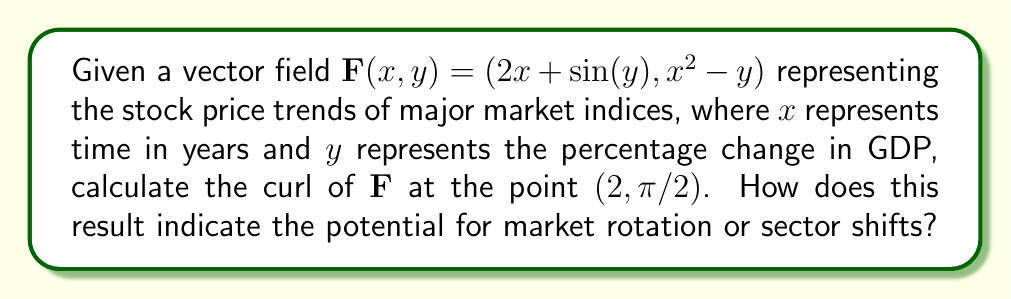Give your solution to this math problem. To solve this problem, we'll follow these steps:

1) The curl of a vector field $\mathbf{F}(x, y) = (P, Q)$ in 2D is given by:

   $$\text{curl } \mathbf{F} = \frac{\partial Q}{\partial x} - \frac{\partial P}{\partial y}$$

2) In our case, $P = 2x + \sin(y)$ and $Q = x^2 - y$

3) Let's calculate the partial derivatives:

   $\frac{\partial Q}{\partial x} = 2x$

   $\frac{\partial P}{\partial y} = \cos(y)$

4) Now, we can calculate the curl:

   $$\text{curl } \mathbf{F} = 2x - \cos(y)$$

5) We need to evaluate this at the point $(2, \pi/2)$:

   $$\text{curl } \mathbf{F}(2, \pi/2) = 2(2) - \cos(\pi/2) = 4 - 0 = 4$$

6) Interpretation: A non-zero curl (4 in this case) indicates rotational behavior in the vector field. In the context of stock markets, this suggests a potential for sector rotation or shifts in market leadership. The positive value implies a counterclockwise rotation, which could indicate a shift from defensive to growth sectors in a bullish market scenario.
Answer: 4; indicates potential counterclockwise sector rotation 